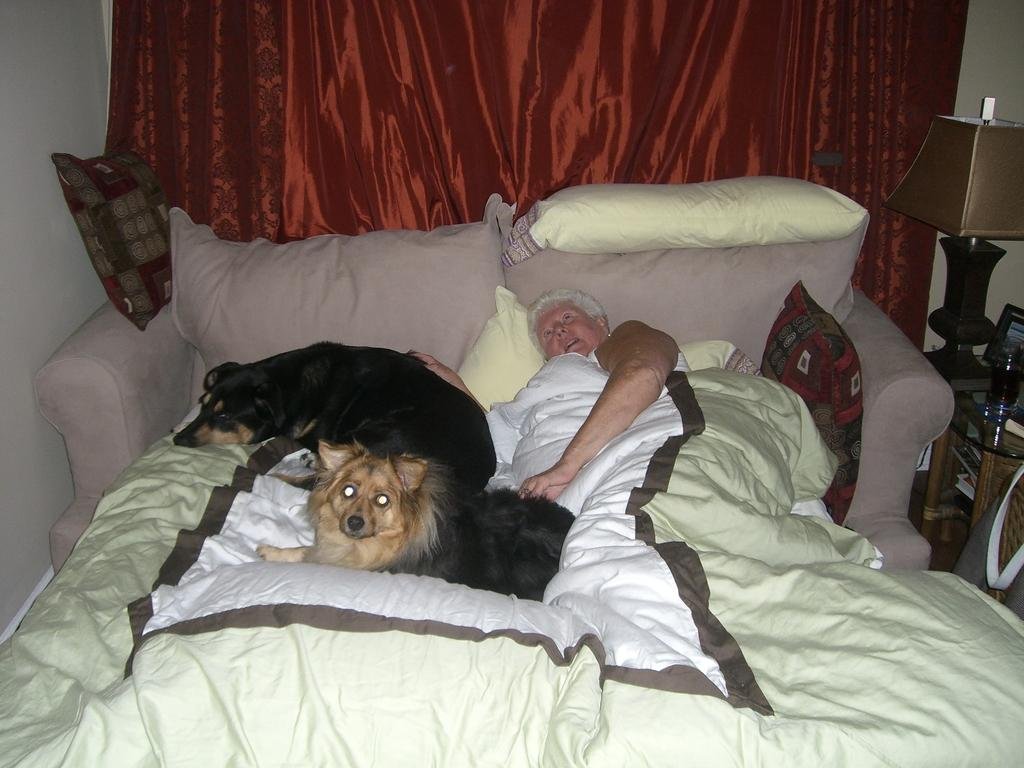What is the color of the wall in the image? The wall in the image is white. What type of window treatment is present in the image? There are curtains in the image. What type of lighting is present in the image? There is a lamp in the image. What type of seating is present in the image? There is a sofa in the image. What type of bedding is present in the image? There are bed sheets in the image. How many dogs are in the image? There are two dogs in the image. What is the woman in the image doing? The woman is sleeping in the image. What is the name of the woman's uncle in the image? There is no information about the woman's uncle in the image. What are the dogs' interests in the image? There is no information about the dogs' interests in the image. 